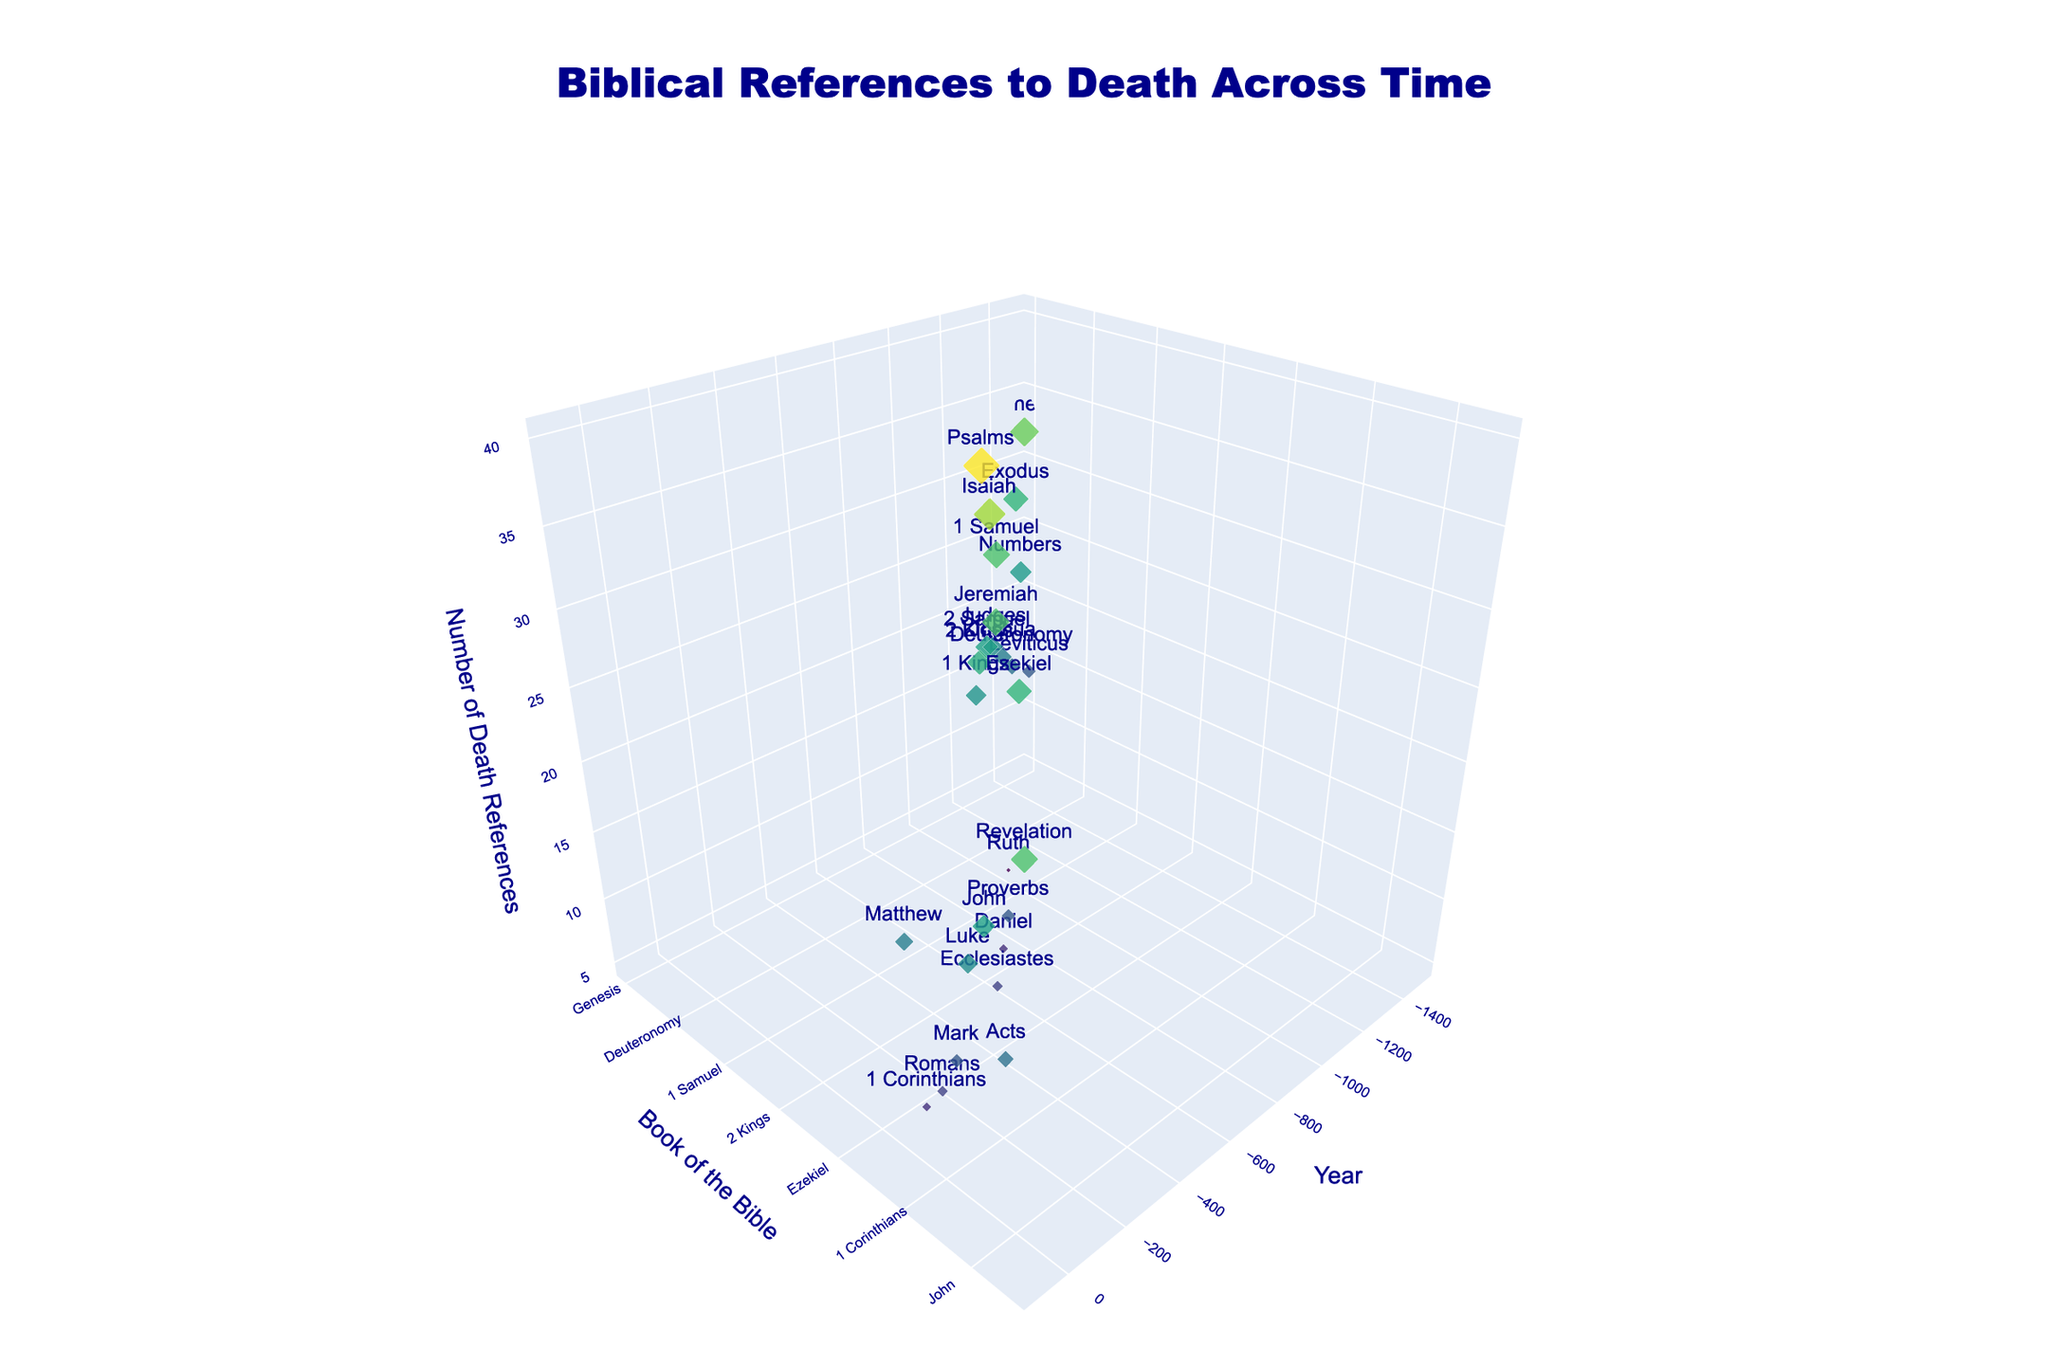what is the title of the 3D plot? The title of a plot is usually displayed prominently at the top to indicate what the visualization represents. In this case, the title "Biblical References to Death Across Time" is clearly visible at the top center of the plot.
Answer: Biblical References to Death Across Time How many books of the Bible are represented in the 3D plot? Each individual book is represented as a unique data point. By counting the number of unique data points, we can determine the number of books. A careful count reveals 24 books.
Answer: 24 Which book has the highest number of death references? To determine the book with the highest number of death references, check the book with the tallest marker in the vertical axis, 'Psalms' showing 40 references.
Answer: Psalms What is the range of years covered in the plot? The year range can be found by looking at the minimum and maximum values on the x-axis. These range from approximately -1500 years to 95 years.
Answer: -1500 to 95 What is the average number of death references across all books? Sum the total number of death references and divide by the number of books: (32 + 28 + 15 + 24 + 18 + 20 + 22 + 5 + 30 + 25 + 23 + 27 + 40 + 15 + 12 + 35 + 30 + 28 + 10 + 20 + 15 + 22 + 25 + 18 + 12 + 10 + 30 = 565) / 24 = 23.54.
Answer: 23.54 Which two books have the closest number of death references? By examining the vertical positions of the markers on the z-axis, 'Acts' and 'Deuteronomy' both have 18 death references.
Answer: Acts and Deuteronomy Are there any books with an equal number of death references? To identify books with equal reference counts, compare vertical positions. Both 'Acts' and 'Deuteronomy' have 18 references, and 'Leviticus' and 'Proverbs' each have 15 references.
Answer: Acts and Deuteronomy, Leviticus and Proverbs Which book features the lowest number of death references, and how many does it have? The book with the shortest marker along the vertical axis has the lowest death references. 'Ruth' has 5 references, the lowest in the dataset.
Answer: Ruth with 5 references How does the number of death references in Genesis compare to that in Revelation? Compare the vertical positions of 'Genesis' and 'Revelation' on the z-axis. Genesis has 32 death references whereas Revelation has 30.
Answer: Genesis has 2 more than Revelation Identify the book with the second-highest number of death references. By first identifying the book with the highest references ('Psalms' with 40), look for the next highest. 'Isaiah' follows with 35.
Answer: Isaiah 